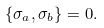Convert formula to latex. <formula><loc_0><loc_0><loc_500><loc_500>\{ \sigma _ { a } , \sigma _ { b } \} = 0 .</formula> 